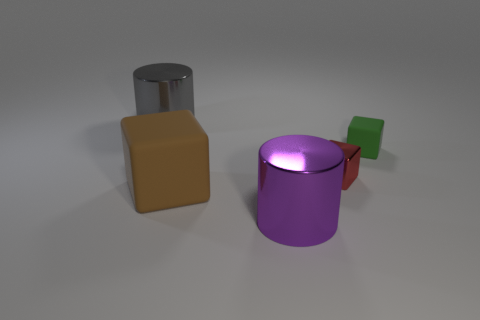There is a big purple thing; is it the same shape as the rubber thing on the right side of the big brown cube?
Provide a succinct answer. No. What number of big purple shiny cylinders are on the left side of the rubber object that is behind the large rubber cube that is on the left side of the tiny green matte block?
Your answer should be very brief. 1. The other metallic thing that is the same shape as the big purple thing is what color?
Provide a succinct answer. Gray. Is there anything else that is the same shape as the large purple metal object?
Make the answer very short. Yes. How many cubes are either large blue metal objects or brown objects?
Keep it short and to the point. 1. What shape is the red shiny object?
Offer a terse response. Cube. There is a tiny green cube; are there any big metallic things in front of it?
Make the answer very short. Yes. Is the material of the large purple cylinder the same as the cylinder behind the small green rubber cube?
Your response must be concise. Yes. There is a metal object behind the small red shiny object; is it the same shape as the big brown rubber thing?
Keep it short and to the point. No. How many things are the same material as the large block?
Offer a terse response. 1. 